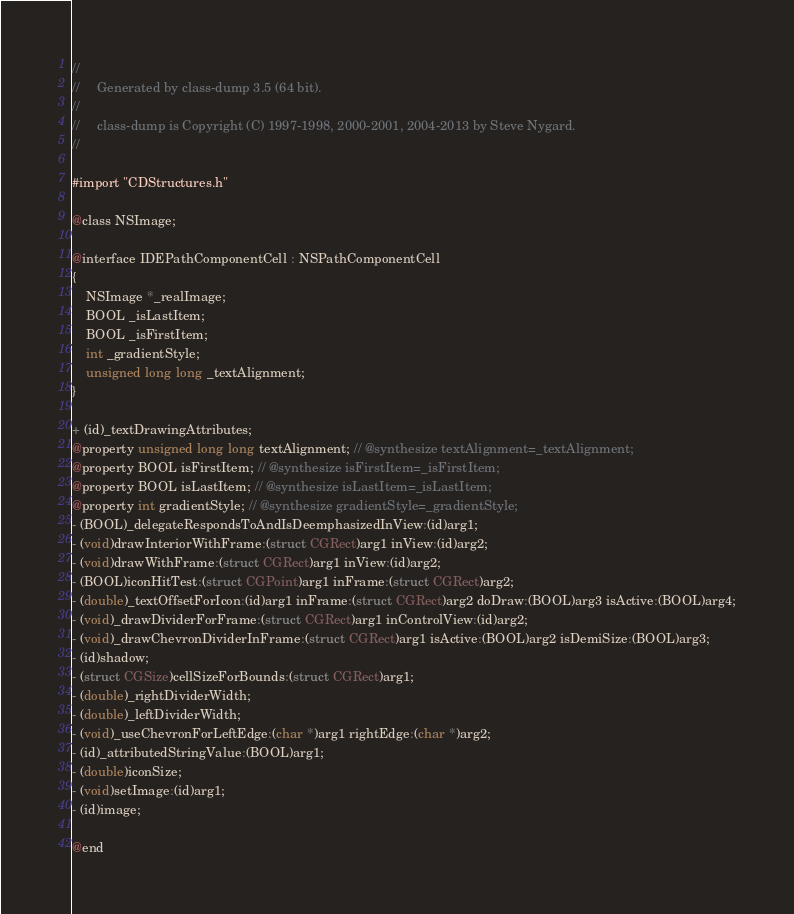Convert code to text. <code><loc_0><loc_0><loc_500><loc_500><_C_>//
//     Generated by class-dump 3.5 (64 bit).
//
//     class-dump is Copyright (C) 1997-1998, 2000-2001, 2004-2013 by Steve Nygard.
//

#import "CDStructures.h"

@class NSImage;

@interface IDEPathComponentCell : NSPathComponentCell
{
    NSImage *_realImage;
    BOOL _isLastItem;
    BOOL _isFirstItem;
    int _gradientStyle;
    unsigned long long _textAlignment;
}

+ (id)_textDrawingAttributes;
@property unsigned long long textAlignment; // @synthesize textAlignment=_textAlignment;
@property BOOL isFirstItem; // @synthesize isFirstItem=_isFirstItem;
@property BOOL isLastItem; // @synthesize isLastItem=_isLastItem;
@property int gradientStyle; // @synthesize gradientStyle=_gradientStyle;
- (BOOL)_delegateRespondsToAndIsDeemphasizedInView:(id)arg1;
- (void)drawInteriorWithFrame:(struct CGRect)arg1 inView:(id)arg2;
- (void)drawWithFrame:(struct CGRect)arg1 inView:(id)arg2;
- (BOOL)iconHitTest:(struct CGPoint)arg1 inFrame:(struct CGRect)arg2;
- (double)_textOffsetForIcon:(id)arg1 inFrame:(struct CGRect)arg2 doDraw:(BOOL)arg3 isActive:(BOOL)arg4;
- (void)_drawDividerForFrame:(struct CGRect)arg1 inControlView:(id)arg2;
- (void)_drawChevronDividerInFrame:(struct CGRect)arg1 isActive:(BOOL)arg2 isDemiSize:(BOOL)arg3;
- (id)shadow;
- (struct CGSize)cellSizeForBounds:(struct CGRect)arg1;
- (double)_rightDividerWidth;
- (double)_leftDividerWidth;
- (void)_useChevronForLeftEdge:(char *)arg1 rightEdge:(char *)arg2;
- (id)_attributedStringValue:(BOOL)arg1;
- (double)iconSize;
- (void)setImage:(id)arg1;
- (id)image;

@end

</code> 